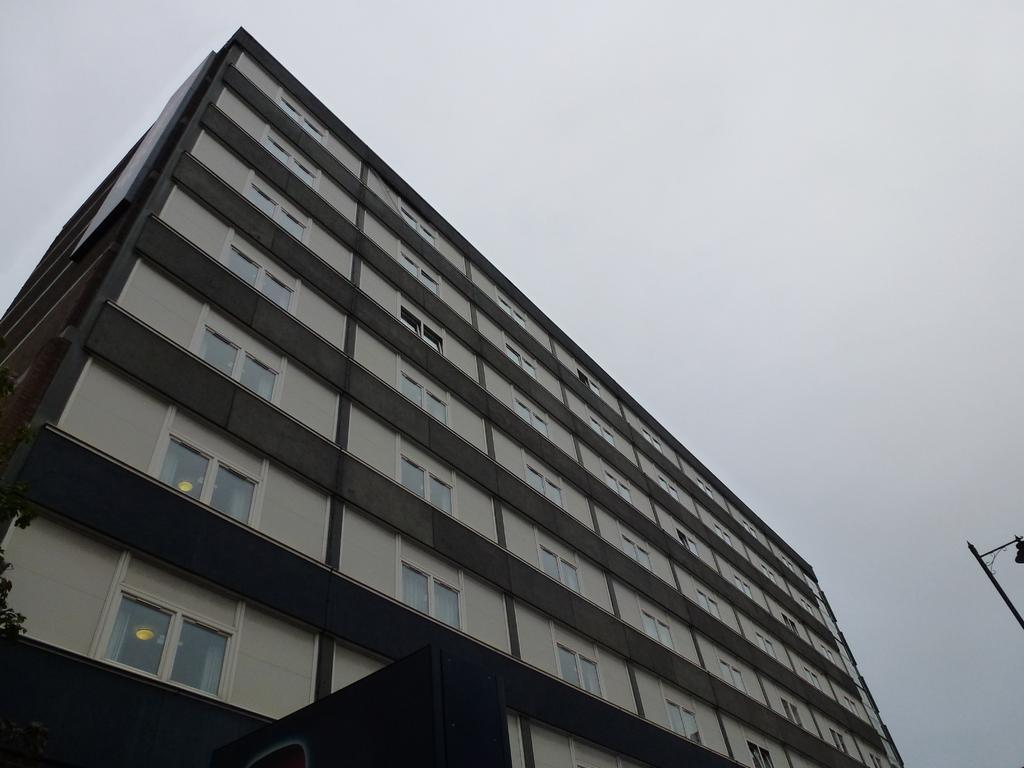Describe this image in one or two sentences. In the image there is a building and on the right side there is a pole. 